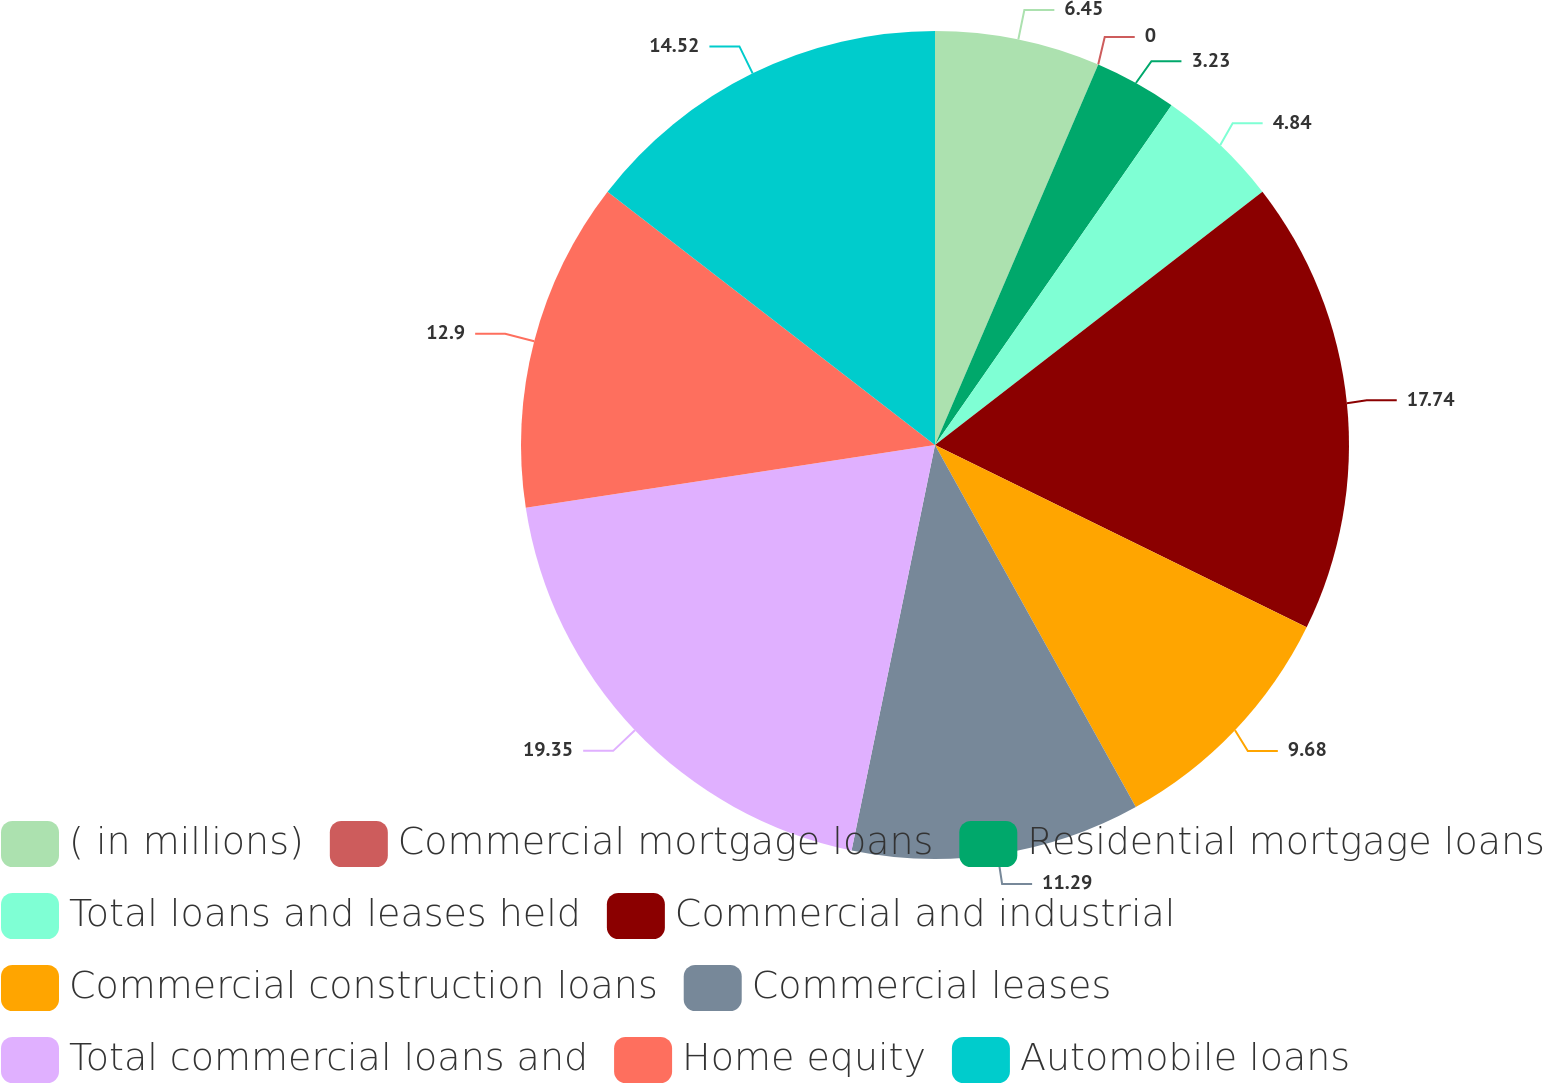<chart> <loc_0><loc_0><loc_500><loc_500><pie_chart><fcel>( in millions)<fcel>Commercial mortgage loans<fcel>Residential mortgage loans<fcel>Total loans and leases held<fcel>Commercial and industrial<fcel>Commercial construction loans<fcel>Commercial leases<fcel>Total commercial loans and<fcel>Home equity<fcel>Automobile loans<nl><fcel>6.45%<fcel>0.0%<fcel>3.23%<fcel>4.84%<fcel>17.74%<fcel>9.68%<fcel>11.29%<fcel>19.35%<fcel>12.9%<fcel>14.52%<nl></chart> 